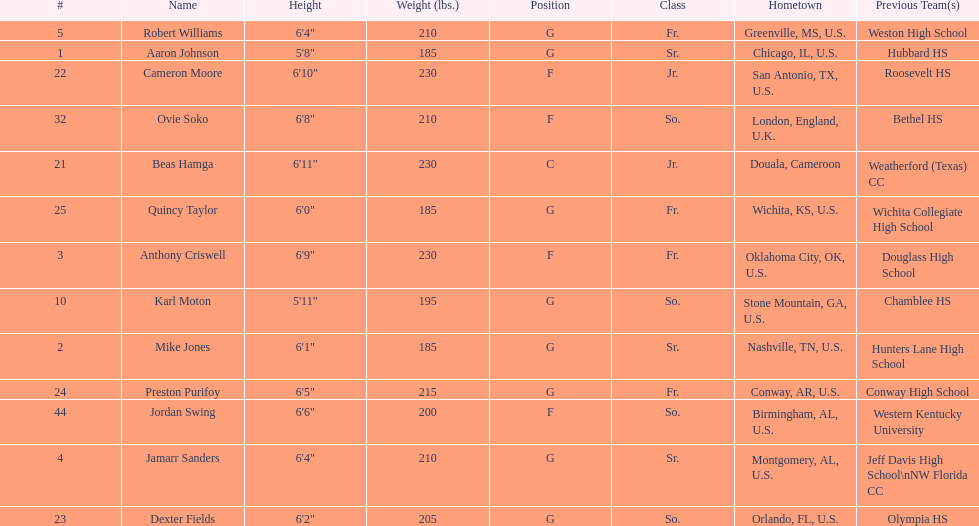How many players were on the 2010-11 uab blazers men's basketball team? 13. 